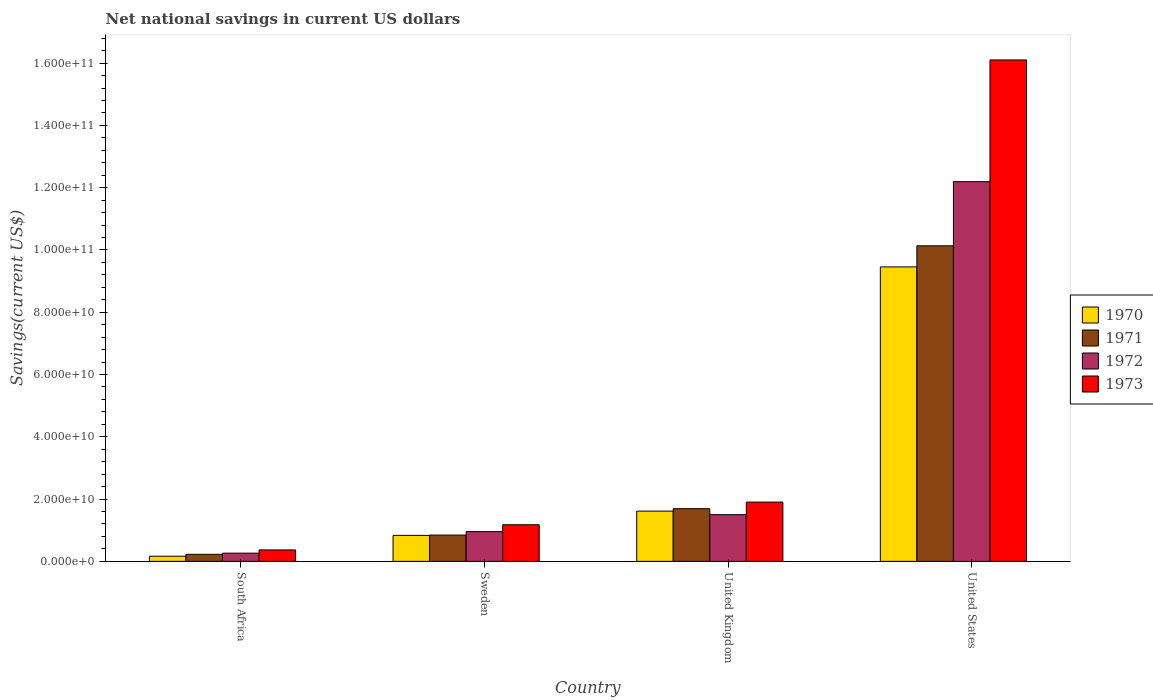How many different coloured bars are there?
Provide a short and direct response. 4. How many bars are there on the 1st tick from the left?
Your answer should be very brief. 4. How many bars are there on the 2nd tick from the right?
Your answer should be very brief. 4. What is the label of the 2nd group of bars from the left?
Keep it short and to the point. Sweden. What is the net national savings in 1972 in United Kingdom?
Your response must be concise. 1.50e+1. Across all countries, what is the maximum net national savings in 1972?
Your answer should be compact. 1.22e+11. Across all countries, what is the minimum net national savings in 1973?
Keep it short and to the point. 3.67e+09. In which country was the net national savings in 1970 maximum?
Keep it short and to the point. United States. In which country was the net national savings in 1970 minimum?
Ensure brevity in your answer.  South Africa. What is the total net national savings in 1970 in the graph?
Provide a short and direct response. 1.21e+11. What is the difference between the net national savings in 1970 in Sweden and that in United Kingdom?
Provide a short and direct response. -7.80e+09. What is the difference between the net national savings in 1970 in Sweden and the net national savings in 1972 in United States?
Provide a succinct answer. -1.14e+11. What is the average net national savings in 1972 per country?
Ensure brevity in your answer.  3.73e+1. What is the difference between the net national savings of/in 1973 and net national savings of/in 1972 in South Africa?
Provide a short and direct response. 1.04e+09. What is the ratio of the net national savings in 1972 in Sweden to that in United Kingdom?
Your answer should be very brief. 0.64. Is the difference between the net national savings in 1973 in Sweden and United States greater than the difference between the net national savings in 1972 in Sweden and United States?
Make the answer very short. No. What is the difference between the highest and the second highest net national savings in 1973?
Provide a short and direct response. 1.42e+11. What is the difference between the highest and the lowest net national savings in 1972?
Ensure brevity in your answer.  1.19e+11. What does the 1st bar from the right in United States represents?
Offer a terse response. 1973. Is it the case that in every country, the sum of the net national savings in 1973 and net national savings in 1972 is greater than the net national savings in 1970?
Offer a terse response. Yes. How many bars are there?
Your answer should be very brief. 16. How many countries are there in the graph?
Ensure brevity in your answer.  4. What is the difference between two consecutive major ticks on the Y-axis?
Provide a succinct answer. 2.00e+1. Are the values on the major ticks of Y-axis written in scientific E-notation?
Keep it short and to the point. Yes. Does the graph contain grids?
Your answer should be compact. No. How many legend labels are there?
Make the answer very short. 4. What is the title of the graph?
Keep it short and to the point. Net national savings in current US dollars. Does "1977" appear as one of the legend labels in the graph?
Offer a terse response. No. What is the label or title of the Y-axis?
Your answer should be very brief. Savings(current US$). What is the Savings(current US$) in 1970 in South Africa?
Your answer should be very brief. 1.66e+09. What is the Savings(current US$) of 1971 in South Africa?
Keep it short and to the point. 2.27e+09. What is the Savings(current US$) of 1972 in South Africa?
Your answer should be compact. 2.64e+09. What is the Savings(current US$) of 1973 in South Africa?
Provide a short and direct response. 3.67e+09. What is the Savings(current US$) in 1970 in Sweden?
Keep it short and to the point. 8.34e+09. What is the Savings(current US$) of 1971 in Sweden?
Your response must be concise. 8.45e+09. What is the Savings(current US$) in 1972 in Sweden?
Ensure brevity in your answer.  9.56e+09. What is the Savings(current US$) of 1973 in Sweden?
Ensure brevity in your answer.  1.18e+1. What is the Savings(current US$) of 1970 in United Kingdom?
Offer a terse response. 1.61e+1. What is the Savings(current US$) in 1971 in United Kingdom?
Your response must be concise. 1.69e+1. What is the Savings(current US$) of 1972 in United Kingdom?
Give a very brief answer. 1.50e+1. What is the Savings(current US$) of 1973 in United Kingdom?
Your answer should be very brief. 1.90e+1. What is the Savings(current US$) of 1970 in United States?
Ensure brevity in your answer.  9.46e+1. What is the Savings(current US$) in 1971 in United States?
Offer a terse response. 1.01e+11. What is the Savings(current US$) of 1972 in United States?
Your answer should be very brief. 1.22e+11. What is the Savings(current US$) of 1973 in United States?
Keep it short and to the point. 1.61e+11. Across all countries, what is the maximum Savings(current US$) in 1970?
Provide a short and direct response. 9.46e+1. Across all countries, what is the maximum Savings(current US$) in 1971?
Give a very brief answer. 1.01e+11. Across all countries, what is the maximum Savings(current US$) of 1972?
Provide a short and direct response. 1.22e+11. Across all countries, what is the maximum Savings(current US$) in 1973?
Offer a terse response. 1.61e+11. Across all countries, what is the minimum Savings(current US$) of 1970?
Your answer should be compact. 1.66e+09. Across all countries, what is the minimum Savings(current US$) in 1971?
Offer a very short reply. 2.27e+09. Across all countries, what is the minimum Savings(current US$) in 1972?
Your answer should be compact. 2.64e+09. Across all countries, what is the minimum Savings(current US$) of 1973?
Provide a short and direct response. 3.67e+09. What is the total Savings(current US$) of 1970 in the graph?
Your response must be concise. 1.21e+11. What is the total Savings(current US$) of 1971 in the graph?
Your answer should be very brief. 1.29e+11. What is the total Savings(current US$) of 1972 in the graph?
Provide a short and direct response. 1.49e+11. What is the total Savings(current US$) of 1973 in the graph?
Keep it short and to the point. 1.95e+11. What is the difference between the Savings(current US$) of 1970 in South Africa and that in Sweden?
Give a very brief answer. -6.69e+09. What is the difference between the Savings(current US$) in 1971 in South Africa and that in Sweden?
Offer a very short reply. -6.18e+09. What is the difference between the Savings(current US$) in 1972 in South Africa and that in Sweden?
Provide a short and direct response. -6.92e+09. What is the difference between the Savings(current US$) in 1973 in South Africa and that in Sweden?
Provide a short and direct response. -8.09e+09. What is the difference between the Savings(current US$) of 1970 in South Africa and that in United Kingdom?
Keep it short and to the point. -1.45e+1. What is the difference between the Savings(current US$) of 1971 in South Africa and that in United Kingdom?
Make the answer very short. -1.46e+1. What is the difference between the Savings(current US$) of 1972 in South Africa and that in United Kingdom?
Give a very brief answer. -1.24e+1. What is the difference between the Savings(current US$) in 1973 in South Africa and that in United Kingdom?
Provide a succinct answer. -1.54e+1. What is the difference between the Savings(current US$) in 1970 in South Africa and that in United States?
Your answer should be compact. -9.29e+1. What is the difference between the Savings(current US$) of 1971 in South Africa and that in United States?
Your response must be concise. -9.91e+1. What is the difference between the Savings(current US$) of 1972 in South Africa and that in United States?
Your response must be concise. -1.19e+11. What is the difference between the Savings(current US$) in 1973 in South Africa and that in United States?
Provide a succinct answer. -1.57e+11. What is the difference between the Savings(current US$) of 1970 in Sweden and that in United Kingdom?
Provide a short and direct response. -7.80e+09. What is the difference between the Savings(current US$) in 1971 in Sweden and that in United Kingdom?
Your response must be concise. -8.46e+09. What is the difference between the Savings(current US$) in 1972 in Sweden and that in United Kingdom?
Provide a succinct answer. -5.43e+09. What is the difference between the Savings(current US$) in 1973 in Sweden and that in United Kingdom?
Keep it short and to the point. -7.27e+09. What is the difference between the Savings(current US$) of 1970 in Sweden and that in United States?
Provide a short and direct response. -8.62e+1. What is the difference between the Savings(current US$) in 1971 in Sweden and that in United States?
Provide a succinct answer. -9.29e+1. What is the difference between the Savings(current US$) of 1972 in Sweden and that in United States?
Your answer should be compact. -1.12e+11. What is the difference between the Savings(current US$) in 1973 in Sweden and that in United States?
Offer a very short reply. -1.49e+11. What is the difference between the Savings(current US$) of 1970 in United Kingdom and that in United States?
Give a very brief answer. -7.84e+1. What is the difference between the Savings(current US$) in 1971 in United Kingdom and that in United States?
Provide a succinct answer. -8.44e+1. What is the difference between the Savings(current US$) of 1972 in United Kingdom and that in United States?
Your response must be concise. -1.07e+11. What is the difference between the Savings(current US$) in 1973 in United Kingdom and that in United States?
Give a very brief answer. -1.42e+11. What is the difference between the Savings(current US$) in 1970 in South Africa and the Savings(current US$) in 1971 in Sweden?
Offer a very short reply. -6.79e+09. What is the difference between the Savings(current US$) of 1970 in South Africa and the Savings(current US$) of 1972 in Sweden?
Your answer should be compact. -7.90e+09. What is the difference between the Savings(current US$) of 1970 in South Africa and the Savings(current US$) of 1973 in Sweden?
Your answer should be very brief. -1.01e+1. What is the difference between the Savings(current US$) of 1971 in South Africa and the Savings(current US$) of 1972 in Sweden?
Offer a terse response. -7.29e+09. What is the difference between the Savings(current US$) in 1971 in South Africa and the Savings(current US$) in 1973 in Sweden?
Your answer should be compact. -9.50e+09. What is the difference between the Savings(current US$) in 1972 in South Africa and the Savings(current US$) in 1973 in Sweden?
Make the answer very short. -9.13e+09. What is the difference between the Savings(current US$) in 1970 in South Africa and the Savings(current US$) in 1971 in United Kingdom?
Your answer should be compact. -1.53e+1. What is the difference between the Savings(current US$) in 1970 in South Africa and the Savings(current US$) in 1972 in United Kingdom?
Provide a short and direct response. -1.33e+1. What is the difference between the Savings(current US$) of 1970 in South Africa and the Savings(current US$) of 1973 in United Kingdom?
Provide a short and direct response. -1.74e+1. What is the difference between the Savings(current US$) of 1971 in South Africa and the Savings(current US$) of 1972 in United Kingdom?
Make the answer very short. -1.27e+1. What is the difference between the Savings(current US$) of 1971 in South Africa and the Savings(current US$) of 1973 in United Kingdom?
Ensure brevity in your answer.  -1.68e+1. What is the difference between the Savings(current US$) of 1972 in South Africa and the Savings(current US$) of 1973 in United Kingdom?
Provide a succinct answer. -1.64e+1. What is the difference between the Savings(current US$) in 1970 in South Africa and the Savings(current US$) in 1971 in United States?
Make the answer very short. -9.97e+1. What is the difference between the Savings(current US$) of 1970 in South Africa and the Savings(current US$) of 1972 in United States?
Your answer should be compact. -1.20e+11. What is the difference between the Savings(current US$) of 1970 in South Africa and the Savings(current US$) of 1973 in United States?
Give a very brief answer. -1.59e+11. What is the difference between the Savings(current US$) of 1971 in South Africa and the Savings(current US$) of 1972 in United States?
Offer a very short reply. -1.20e+11. What is the difference between the Savings(current US$) in 1971 in South Africa and the Savings(current US$) in 1973 in United States?
Ensure brevity in your answer.  -1.59e+11. What is the difference between the Savings(current US$) in 1972 in South Africa and the Savings(current US$) in 1973 in United States?
Offer a very short reply. -1.58e+11. What is the difference between the Savings(current US$) of 1970 in Sweden and the Savings(current US$) of 1971 in United Kingdom?
Your answer should be compact. -8.57e+09. What is the difference between the Savings(current US$) of 1970 in Sweden and the Savings(current US$) of 1972 in United Kingdom?
Provide a short and direct response. -6.65e+09. What is the difference between the Savings(current US$) in 1970 in Sweden and the Savings(current US$) in 1973 in United Kingdom?
Offer a terse response. -1.07e+1. What is the difference between the Savings(current US$) of 1971 in Sweden and the Savings(current US$) of 1972 in United Kingdom?
Give a very brief answer. -6.54e+09. What is the difference between the Savings(current US$) of 1971 in Sweden and the Savings(current US$) of 1973 in United Kingdom?
Provide a short and direct response. -1.06e+1. What is the difference between the Savings(current US$) in 1972 in Sweden and the Savings(current US$) in 1973 in United Kingdom?
Your response must be concise. -9.48e+09. What is the difference between the Savings(current US$) of 1970 in Sweden and the Savings(current US$) of 1971 in United States?
Your answer should be very brief. -9.30e+1. What is the difference between the Savings(current US$) in 1970 in Sweden and the Savings(current US$) in 1972 in United States?
Offer a terse response. -1.14e+11. What is the difference between the Savings(current US$) of 1970 in Sweden and the Savings(current US$) of 1973 in United States?
Your answer should be very brief. -1.53e+11. What is the difference between the Savings(current US$) of 1971 in Sweden and the Savings(current US$) of 1972 in United States?
Ensure brevity in your answer.  -1.13e+11. What is the difference between the Savings(current US$) of 1971 in Sweden and the Savings(current US$) of 1973 in United States?
Your answer should be compact. -1.53e+11. What is the difference between the Savings(current US$) in 1972 in Sweden and the Savings(current US$) in 1973 in United States?
Provide a succinct answer. -1.51e+11. What is the difference between the Savings(current US$) in 1970 in United Kingdom and the Savings(current US$) in 1971 in United States?
Provide a short and direct response. -8.52e+1. What is the difference between the Savings(current US$) of 1970 in United Kingdom and the Savings(current US$) of 1972 in United States?
Keep it short and to the point. -1.06e+11. What is the difference between the Savings(current US$) of 1970 in United Kingdom and the Savings(current US$) of 1973 in United States?
Your answer should be very brief. -1.45e+11. What is the difference between the Savings(current US$) in 1971 in United Kingdom and the Savings(current US$) in 1972 in United States?
Provide a short and direct response. -1.05e+11. What is the difference between the Savings(current US$) in 1971 in United Kingdom and the Savings(current US$) in 1973 in United States?
Your response must be concise. -1.44e+11. What is the difference between the Savings(current US$) of 1972 in United Kingdom and the Savings(current US$) of 1973 in United States?
Your answer should be compact. -1.46e+11. What is the average Savings(current US$) of 1970 per country?
Your answer should be compact. 3.02e+1. What is the average Savings(current US$) of 1971 per country?
Offer a terse response. 3.22e+1. What is the average Savings(current US$) of 1972 per country?
Your response must be concise. 3.73e+1. What is the average Savings(current US$) in 1973 per country?
Give a very brief answer. 4.89e+1. What is the difference between the Savings(current US$) in 1970 and Savings(current US$) in 1971 in South Africa?
Provide a short and direct response. -6.09e+08. What is the difference between the Savings(current US$) in 1970 and Savings(current US$) in 1972 in South Africa?
Your answer should be very brief. -9.79e+08. What is the difference between the Savings(current US$) in 1970 and Savings(current US$) in 1973 in South Africa?
Your answer should be very brief. -2.02e+09. What is the difference between the Savings(current US$) in 1971 and Savings(current US$) in 1972 in South Africa?
Provide a succinct answer. -3.70e+08. What is the difference between the Savings(current US$) of 1971 and Savings(current US$) of 1973 in South Africa?
Ensure brevity in your answer.  -1.41e+09. What is the difference between the Savings(current US$) of 1972 and Savings(current US$) of 1973 in South Africa?
Your answer should be very brief. -1.04e+09. What is the difference between the Savings(current US$) in 1970 and Savings(current US$) in 1971 in Sweden?
Your response must be concise. -1.07e+08. What is the difference between the Savings(current US$) in 1970 and Savings(current US$) in 1972 in Sweden?
Your response must be concise. -1.22e+09. What is the difference between the Savings(current US$) in 1970 and Savings(current US$) in 1973 in Sweden?
Your response must be concise. -3.42e+09. What is the difference between the Savings(current US$) in 1971 and Savings(current US$) in 1972 in Sweden?
Provide a short and direct response. -1.11e+09. What is the difference between the Savings(current US$) in 1971 and Savings(current US$) in 1973 in Sweden?
Your answer should be very brief. -3.31e+09. What is the difference between the Savings(current US$) in 1972 and Savings(current US$) in 1973 in Sweden?
Give a very brief answer. -2.20e+09. What is the difference between the Savings(current US$) of 1970 and Savings(current US$) of 1971 in United Kingdom?
Offer a terse response. -7.74e+08. What is the difference between the Savings(current US$) in 1970 and Savings(current US$) in 1972 in United Kingdom?
Your answer should be compact. 1.15e+09. What is the difference between the Savings(current US$) in 1970 and Savings(current US$) in 1973 in United Kingdom?
Give a very brief answer. -2.90e+09. What is the difference between the Savings(current US$) of 1971 and Savings(current US$) of 1972 in United Kingdom?
Offer a very short reply. 1.92e+09. What is the difference between the Savings(current US$) of 1971 and Savings(current US$) of 1973 in United Kingdom?
Offer a terse response. -2.12e+09. What is the difference between the Savings(current US$) in 1972 and Savings(current US$) in 1973 in United Kingdom?
Offer a very short reply. -4.04e+09. What is the difference between the Savings(current US$) in 1970 and Savings(current US$) in 1971 in United States?
Provide a short and direct response. -6.78e+09. What is the difference between the Savings(current US$) in 1970 and Savings(current US$) in 1972 in United States?
Your answer should be compact. -2.74e+1. What is the difference between the Savings(current US$) in 1970 and Savings(current US$) in 1973 in United States?
Give a very brief answer. -6.65e+1. What is the difference between the Savings(current US$) of 1971 and Savings(current US$) of 1972 in United States?
Your response must be concise. -2.06e+1. What is the difference between the Savings(current US$) of 1971 and Savings(current US$) of 1973 in United States?
Offer a terse response. -5.97e+1. What is the difference between the Savings(current US$) of 1972 and Savings(current US$) of 1973 in United States?
Offer a terse response. -3.91e+1. What is the ratio of the Savings(current US$) of 1970 in South Africa to that in Sweden?
Keep it short and to the point. 0.2. What is the ratio of the Savings(current US$) of 1971 in South Africa to that in Sweden?
Give a very brief answer. 0.27. What is the ratio of the Savings(current US$) of 1972 in South Africa to that in Sweden?
Give a very brief answer. 0.28. What is the ratio of the Savings(current US$) in 1973 in South Africa to that in Sweden?
Your answer should be compact. 0.31. What is the ratio of the Savings(current US$) of 1970 in South Africa to that in United Kingdom?
Provide a succinct answer. 0.1. What is the ratio of the Savings(current US$) in 1971 in South Africa to that in United Kingdom?
Offer a very short reply. 0.13. What is the ratio of the Savings(current US$) of 1972 in South Africa to that in United Kingdom?
Keep it short and to the point. 0.18. What is the ratio of the Savings(current US$) in 1973 in South Africa to that in United Kingdom?
Keep it short and to the point. 0.19. What is the ratio of the Savings(current US$) in 1970 in South Africa to that in United States?
Your answer should be very brief. 0.02. What is the ratio of the Savings(current US$) in 1971 in South Africa to that in United States?
Ensure brevity in your answer.  0.02. What is the ratio of the Savings(current US$) in 1972 in South Africa to that in United States?
Offer a terse response. 0.02. What is the ratio of the Savings(current US$) of 1973 in South Africa to that in United States?
Give a very brief answer. 0.02. What is the ratio of the Savings(current US$) in 1970 in Sweden to that in United Kingdom?
Your response must be concise. 0.52. What is the ratio of the Savings(current US$) of 1971 in Sweden to that in United Kingdom?
Your answer should be very brief. 0.5. What is the ratio of the Savings(current US$) in 1972 in Sweden to that in United Kingdom?
Offer a terse response. 0.64. What is the ratio of the Savings(current US$) in 1973 in Sweden to that in United Kingdom?
Give a very brief answer. 0.62. What is the ratio of the Savings(current US$) of 1970 in Sweden to that in United States?
Provide a short and direct response. 0.09. What is the ratio of the Savings(current US$) of 1971 in Sweden to that in United States?
Offer a very short reply. 0.08. What is the ratio of the Savings(current US$) of 1972 in Sweden to that in United States?
Give a very brief answer. 0.08. What is the ratio of the Savings(current US$) of 1973 in Sweden to that in United States?
Offer a terse response. 0.07. What is the ratio of the Savings(current US$) of 1970 in United Kingdom to that in United States?
Your response must be concise. 0.17. What is the ratio of the Savings(current US$) in 1971 in United Kingdom to that in United States?
Your response must be concise. 0.17. What is the ratio of the Savings(current US$) in 1972 in United Kingdom to that in United States?
Offer a very short reply. 0.12. What is the ratio of the Savings(current US$) in 1973 in United Kingdom to that in United States?
Make the answer very short. 0.12. What is the difference between the highest and the second highest Savings(current US$) in 1970?
Keep it short and to the point. 7.84e+1. What is the difference between the highest and the second highest Savings(current US$) in 1971?
Your answer should be compact. 8.44e+1. What is the difference between the highest and the second highest Savings(current US$) of 1972?
Your answer should be compact. 1.07e+11. What is the difference between the highest and the second highest Savings(current US$) in 1973?
Offer a terse response. 1.42e+11. What is the difference between the highest and the lowest Savings(current US$) in 1970?
Provide a succinct answer. 9.29e+1. What is the difference between the highest and the lowest Savings(current US$) in 1971?
Give a very brief answer. 9.91e+1. What is the difference between the highest and the lowest Savings(current US$) in 1972?
Your answer should be very brief. 1.19e+11. What is the difference between the highest and the lowest Savings(current US$) of 1973?
Your answer should be very brief. 1.57e+11. 